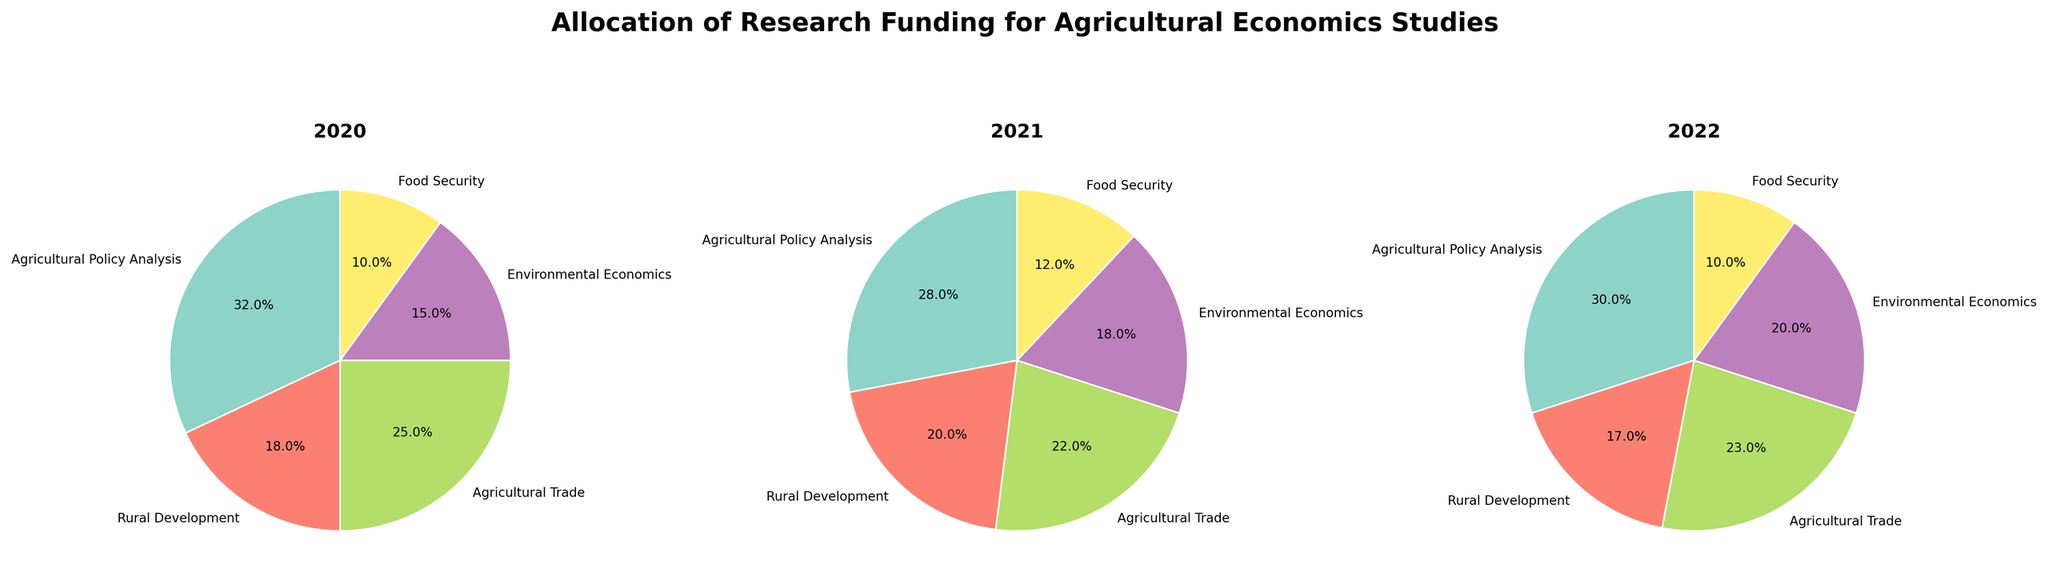What is the title of the figure? The title of the figure is written at the top and it reads "Allocation of Research Funding for Agricultural Economics Studies".
Answer: Allocation of Research Funding for Agricultural Economics Studies Which focus area received the highest percentage of funding allocation in 2020? By looking at the pie chart for 2020, the segment labeled "Agricultural Policy Analysis" is the largest. The percentage is indicated as 32%.
Answer: Agricultural Policy Analysis What is the funding allocation percentage for Environmental Economics in 2021? The pie chart for 2021 shows the segment for "Environmental Economics" along with its percentage allocation, which is labeled as 18%.
Answer: 18% Compare the funding allocated to Food Security between 2020 and 2022. Food Security funding in 2020 is marked at 10%, while in 2022, it also remains at 10%. By comparing these values, we see there is no change.
Answer: No change What is the total funding allocation for Agricultural Trade over the three years (2020-2022)? Adding up the percentages from each year's pie chart: 2020 (25%) + 2021 (22%) + 2022 (23%) results in a total of 70%.
Answer: 70% Which year has the highest percentage of funding for Rural Development? By comparing the pie charts, the largest segment for Rural Development appears in 2021 at 20%.
Answer: 2021 How did the percentage allocation for Agricultural Policy Analysis change from 2020 to 2021? In 2020, the allocation was 32%; in 2021, it decreased to 28%. The difference is calculated as 32% - 28% = 4%.
Answer: Decreased by 4% Calculate the average funding allocation percentage for Environmental Economics over the three years. The percentages for Environmental Economics are 15% (2020), 18% (2021), and 20% (2022). The average is calculated as (15 + 18 + 20) / 3 = 17.67%.
Answer: 17.67% Which focus area has consistently received funding allocations in all three years within the 10% to 20% range? By observing the pie charts, Food Security's allocation is 10% for all three years, which fits within the 10%-20% range consistently.
Answer: Food Security 